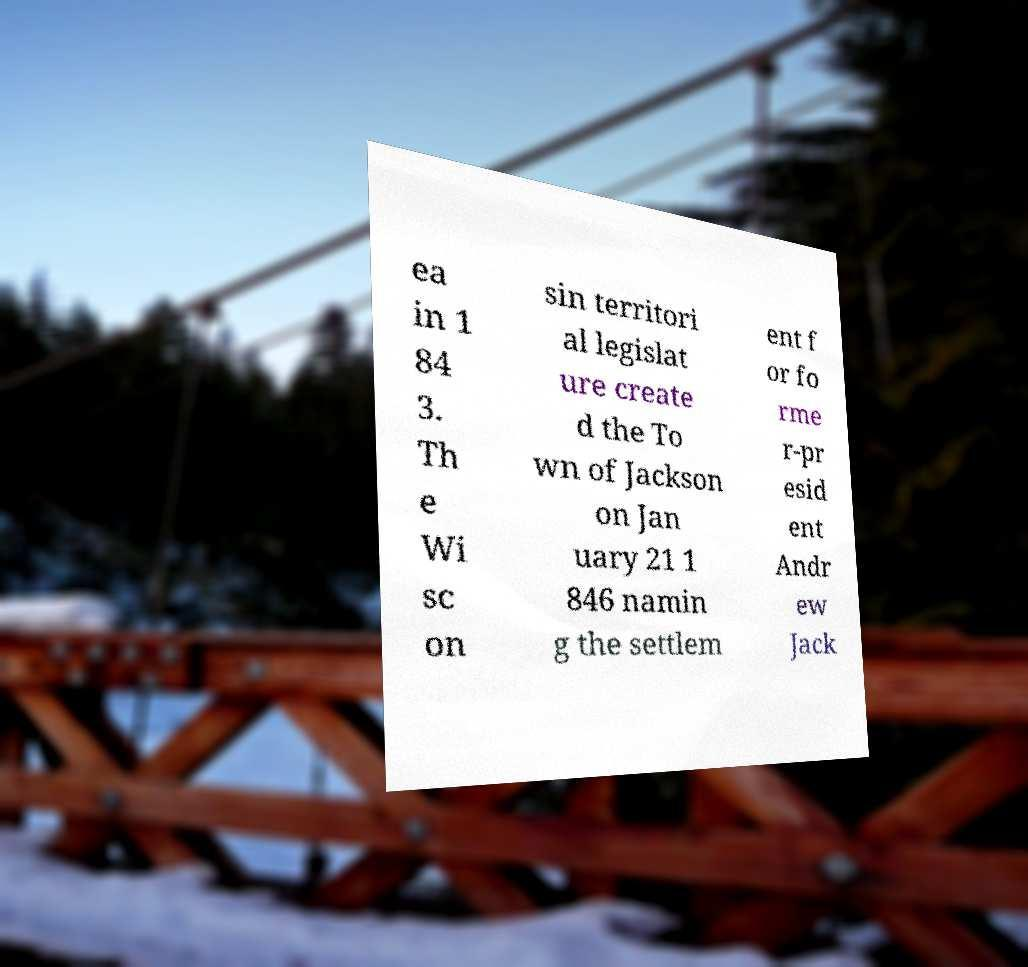I need the written content from this picture converted into text. Can you do that? ea in 1 84 3. Th e Wi sc on sin territori al legislat ure create d the To wn of Jackson on Jan uary 21 1 846 namin g the settlem ent f or fo rme r-pr esid ent Andr ew Jack 